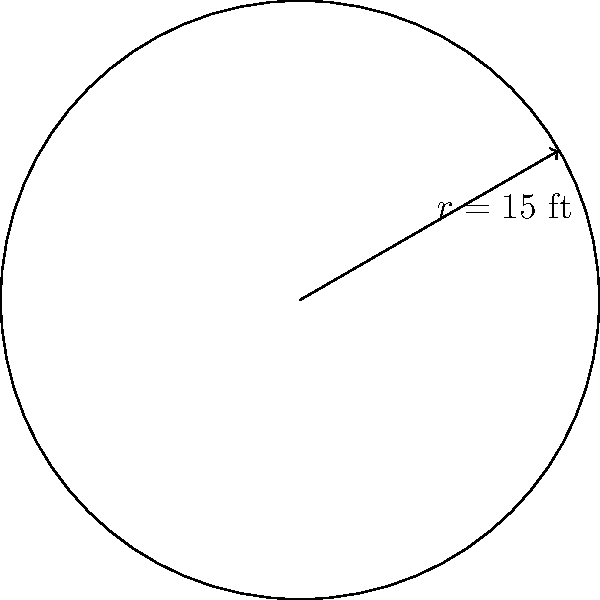You're considering a house with a circular backyard. If the radius of the backyard is 15 feet, what is the total area in square feet? To calculate the area of a circular backyard, we'll use the formula for the area of a circle:

1. The formula for the area of a circle is $A = \pi r^2$, where $r$ is the radius.

2. We're given that the radius is 15 feet.

3. Let's substitute this into our formula:
   $A = \pi (15)^2$

4. Simplify the exponent:
   $A = \pi (225)$

5. Multiply:
   $A = 706.86$ square feet (rounded to two decimal places)

Therefore, the total area of the circular backyard is approximately 706.86 square feet.
Answer: $706.86$ sq ft 